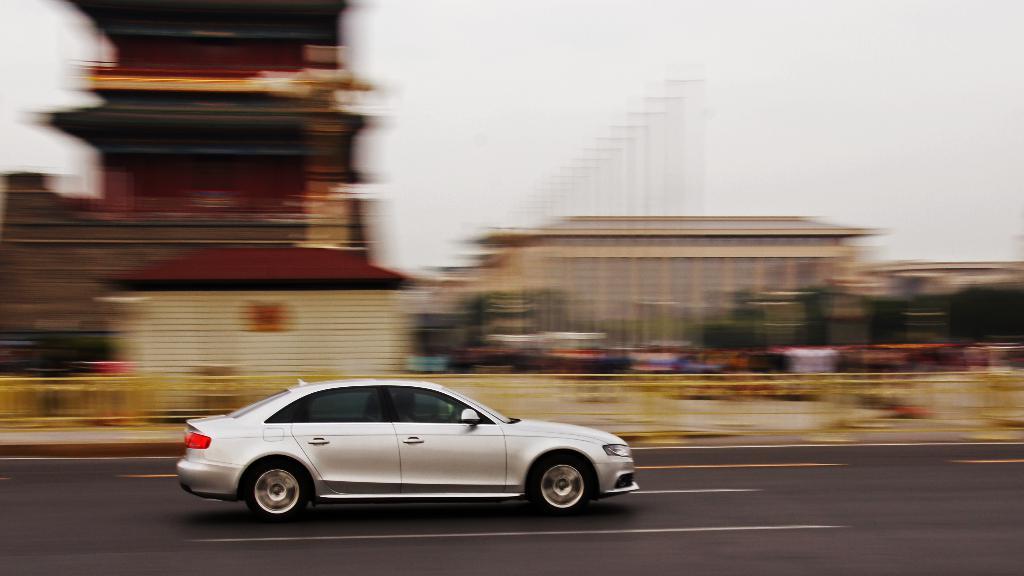Please provide a concise description of this image. In this image I can see a vehicle which is in white color and I can see blurred background and sky is in white color. 